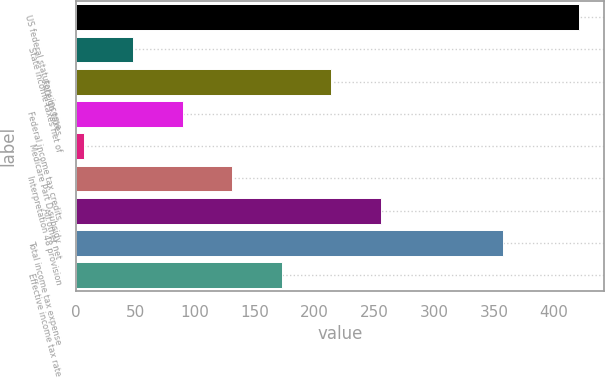Convert chart to OTSL. <chart><loc_0><loc_0><loc_500><loc_500><bar_chart><fcel>US federal statutory income<fcel>State income taxes net of<fcel>Foreign taxes<fcel>Federal income tax credits<fcel>Medicare Part D subsidy<fcel>Interpretation 48 provision<fcel>All other net<fcel>Total income tax expense<fcel>Effective income tax rate<nl><fcel>421<fcel>48.4<fcel>214<fcel>89.8<fcel>7<fcel>131.2<fcel>255.4<fcel>358<fcel>172.6<nl></chart> 